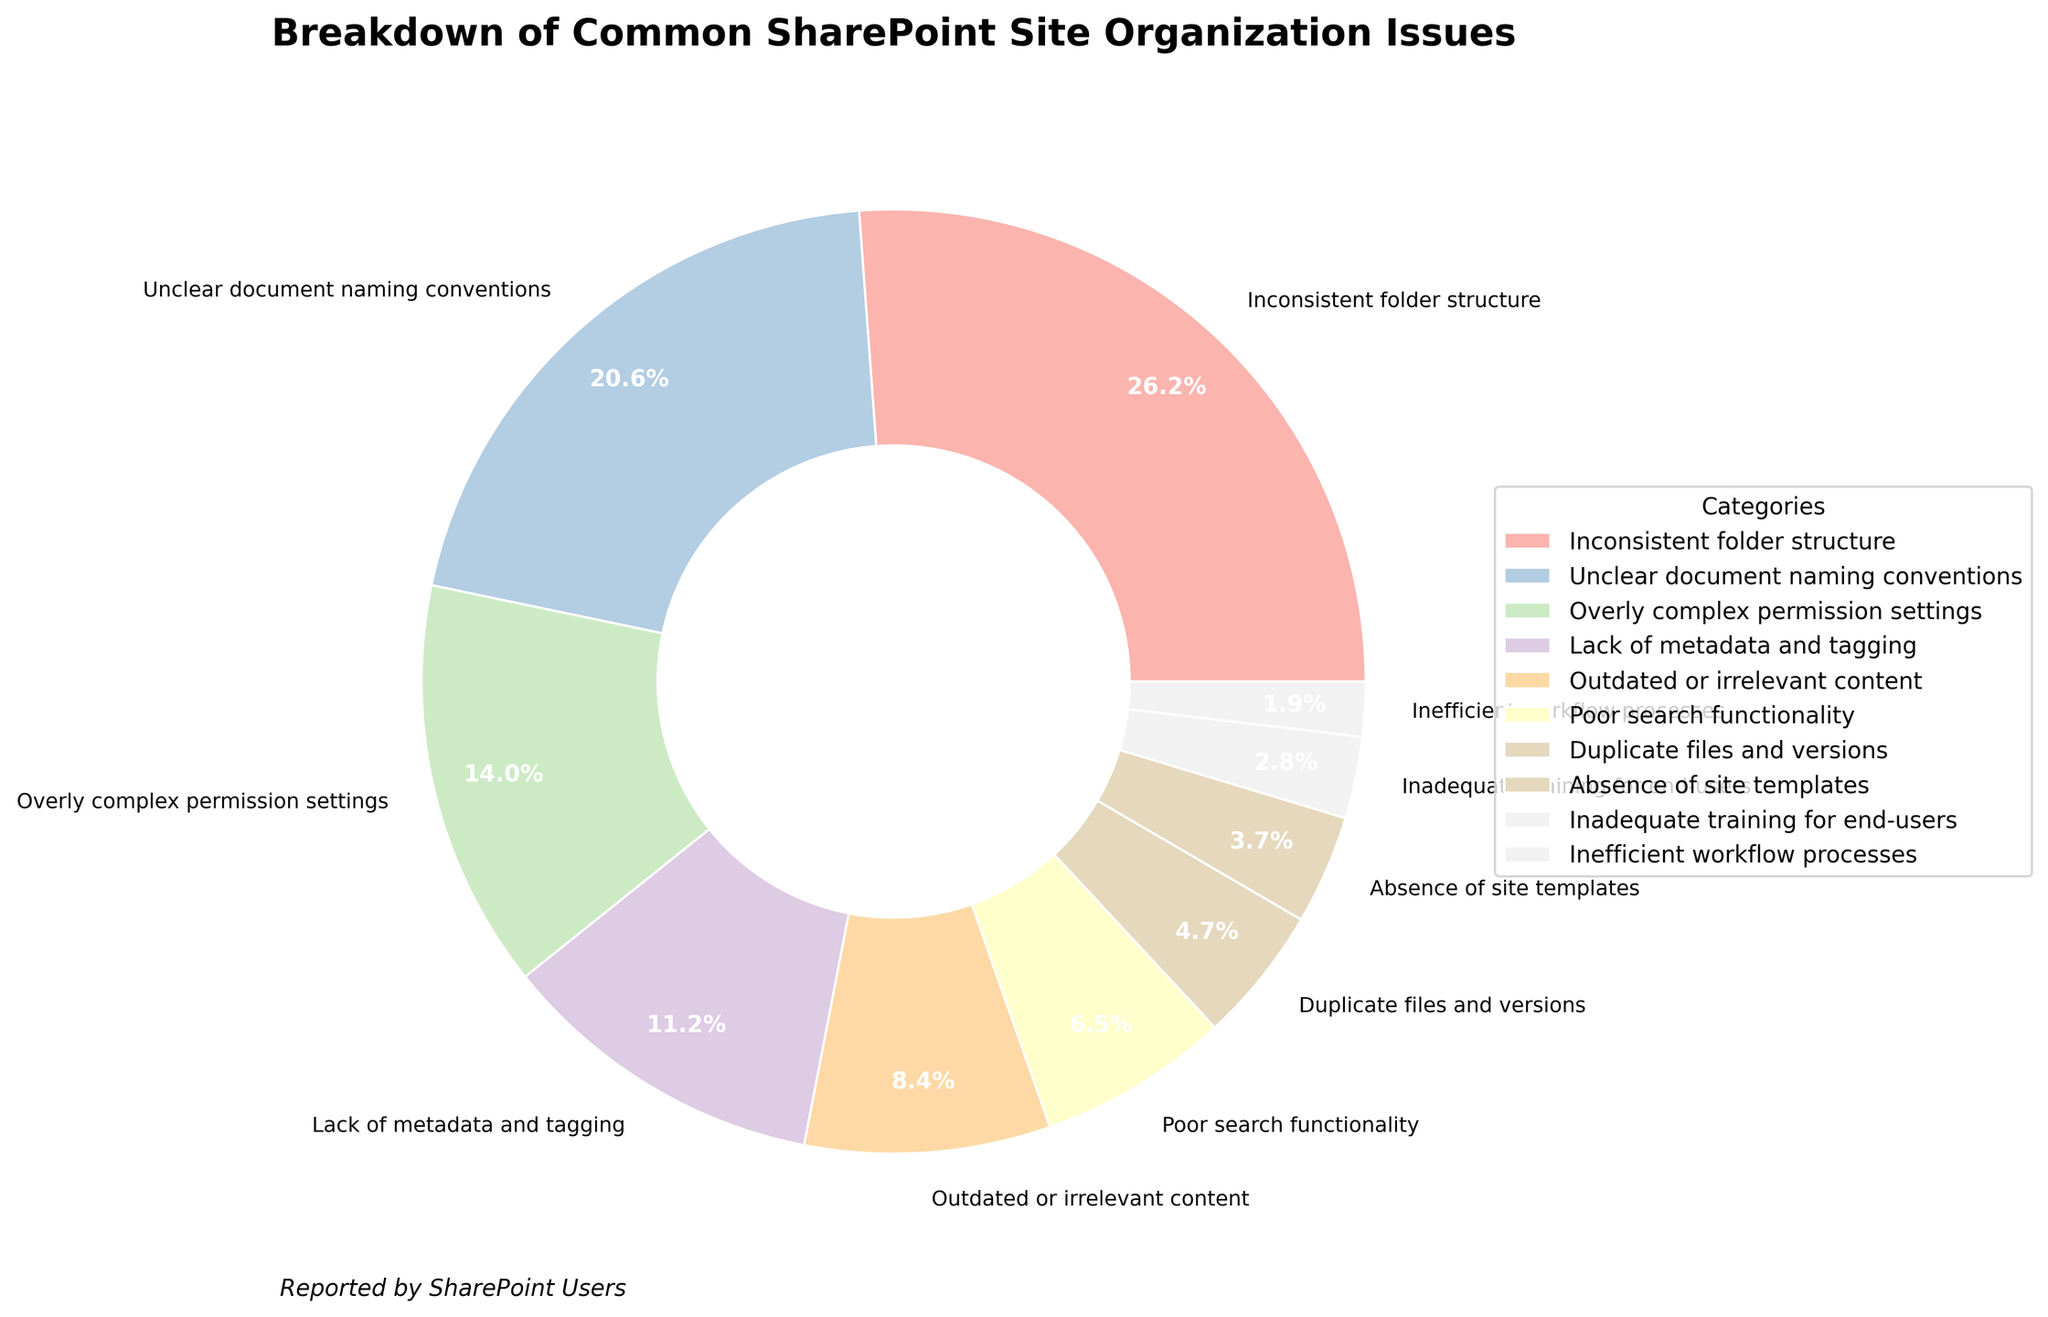What's the largest issue reported by users? Look at the pie chart and identify the category with the largest percentage. 'Inconsistent folder structure' has the highest value.
Answer: Inconsistent folder structure What percentage of issues are due to 'Overly complex permission settings' and 'Unclear document naming conventions' combined? Add the percentages for 'Overly complex permission settings' (15%) and 'Unclear document naming conventions' (22%). This gives 15 + 22 = 37%.
Answer: 37% Which issue is reported more frequently: 'Outdated or irrelevant content' or 'Poor search functionality'? Compare the percentages for 'Outdated or irrelevant content' (9%) and 'Poor search functionality' (7%). 9% is greater than 7%.
Answer: Outdated or irrelevant content What is the least reported issue? Identify the category with the smallest percentage on the pie chart. 'Inefficient workflow processes' has the smallest value.
Answer: Inefficient workflow processes What is the total percentage of issues categorized under 'Lack of metadata and tagging', 'Duplicate files and versions', and 'Absence of site templates'? Sum the percentages for 'Lack of metadata and tagging' (12%), 'Duplicate files and versions' (5%), and 'Absence of site templates' (4%). This gives 12 + 5 + 4 = 21%.
Answer: 21% How does the percentage of 'Inadequate training for end-users' compare to 'Duplicate files and versions'? Compare their percentages: 'Inadequate training for end-users' (3%) is less than 'Duplicate files and versions' (5%).
Answer: Less Which issue is more prevalent: 'Lack of metadata and tagging' or 'Unclear document naming conventions'? Compare their percentages: 'Lack of metadata and tagging' (12%) and 'Unclear document naming conventions' (22%). 22% is greater than 12%.
Answer: Unclear document naming conventions If we remove the issues accounting for less than 5%, what percentage of issues remain? Identify the issues with less than 5%: 'Absence of site templates' (4%), 'Inadequate training for end-users' (3%), 'Inefficient workflow processes' (2%). Their total combined is 4 + 3 + 2 = 9%. Subtract this from 100% to find the remaining percentage: 100 - 9 = 91%.
Answer: 91% What are the two most significant contributors to SharePoint site organization issues? Look at the sectors of the pie chart with the highest percentages. 'Inconsistent folder structure' (28%) and 'Unclear document naming conventions' (22%) are the highest.
Answer: Inconsistent folder structure and Unclear document naming conventions 